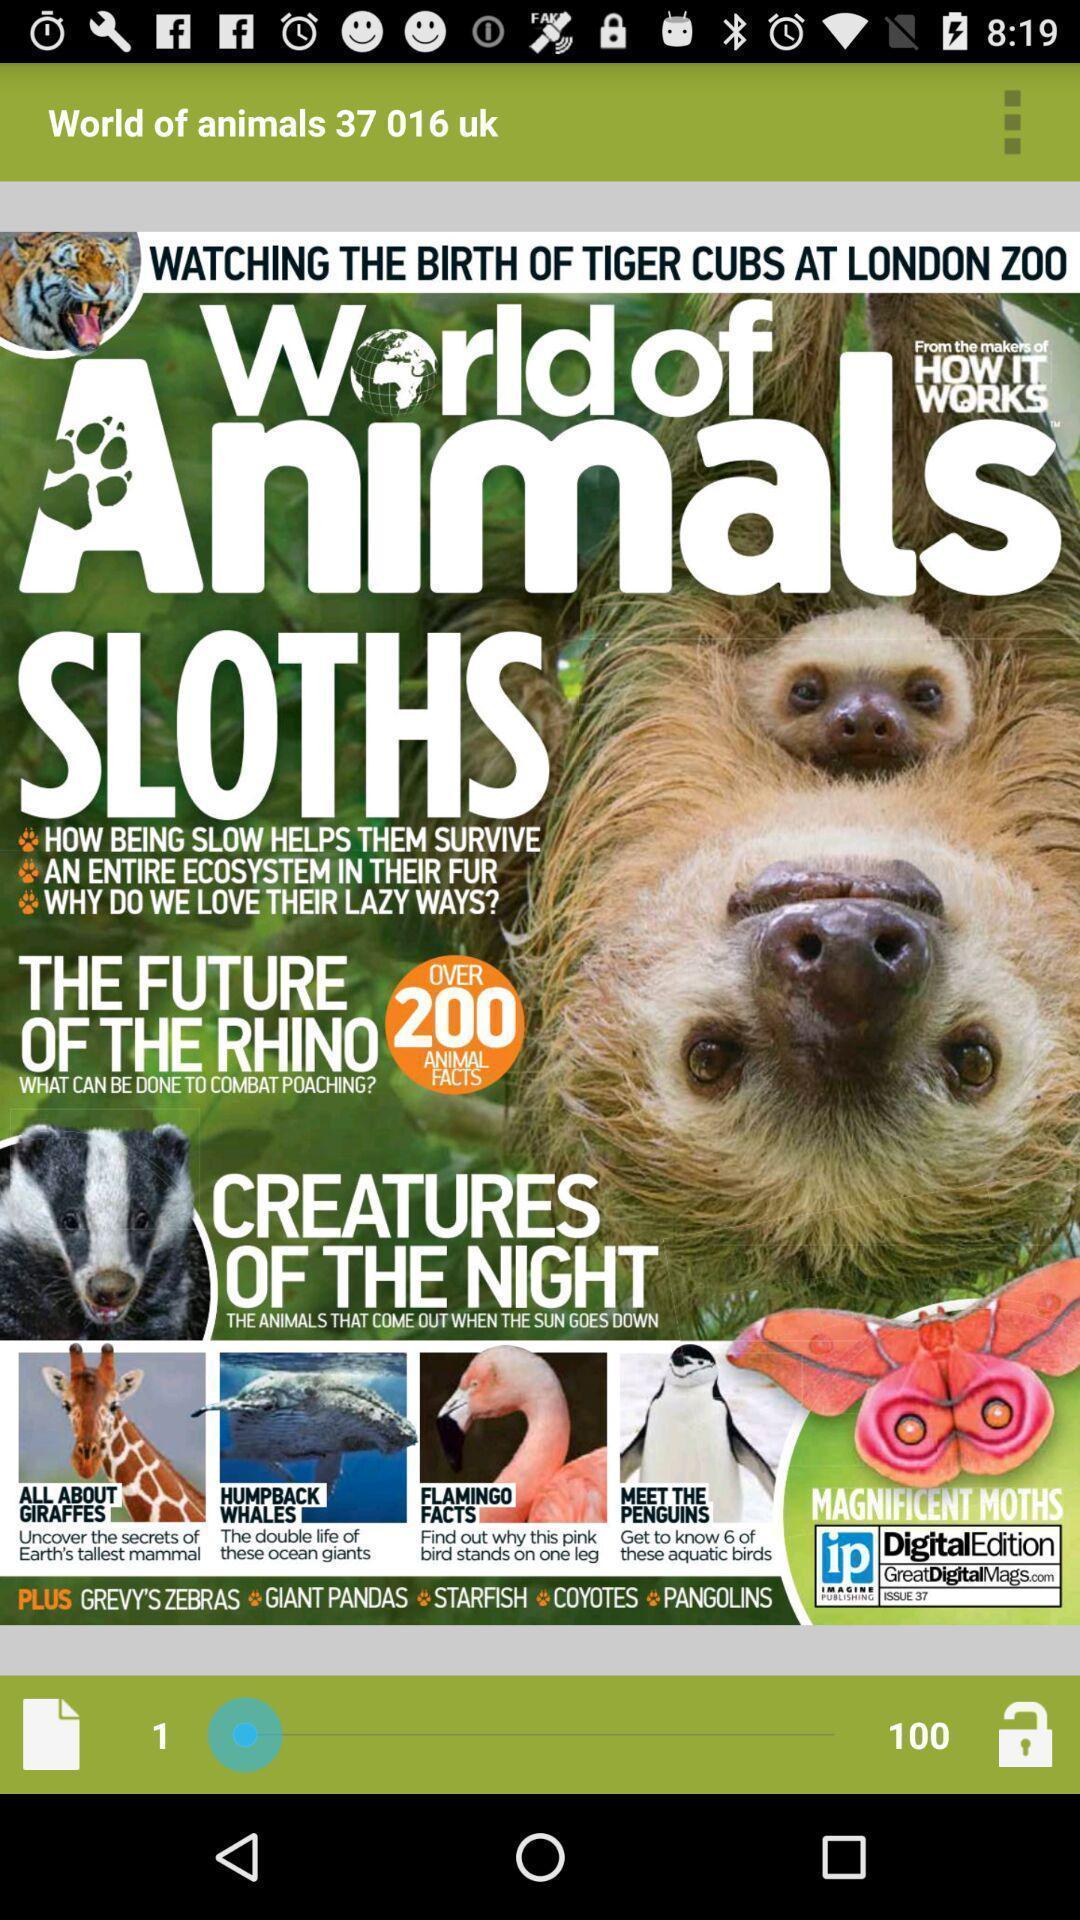Tell me about the visual elements in this screen capture. World of animals book in the app. 